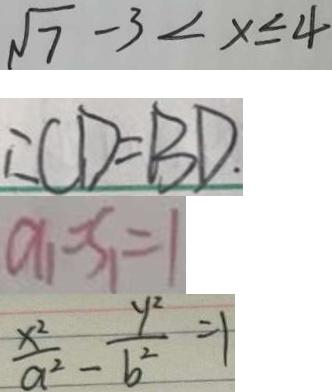<formula> <loc_0><loc_0><loc_500><loc_500>\sqrt { 7 } - 3 < x \leq 4 
 \therefore C D = B D . 
 a _ { 1 } = S _ { 1 } = 1 
 \frac { x ^ { 2 } } { a ^ { 2 } } - \frac { y ^ { 2 } } { b ^ { 2 } } = 1</formula> 